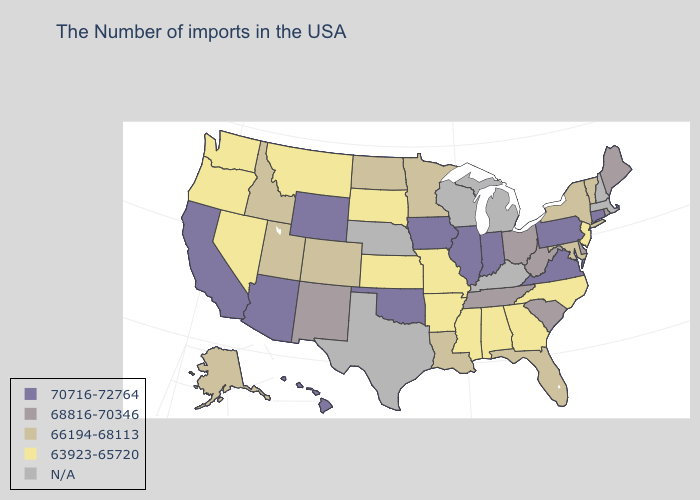What is the value of Alaska?
Write a very short answer. 66194-68113. Among the states that border Connecticut , does Rhode Island have the lowest value?
Concise answer only. No. Among the states that border Iowa , does South Dakota have the highest value?
Write a very short answer. No. Does the first symbol in the legend represent the smallest category?
Answer briefly. No. What is the highest value in the Northeast ?
Short answer required. 70716-72764. Which states have the highest value in the USA?
Concise answer only. Connecticut, Pennsylvania, Virginia, Indiana, Illinois, Iowa, Oklahoma, Wyoming, Arizona, California, Hawaii. What is the value of Michigan?
Be succinct. N/A. Which states have the lowest value in the USA?
Answer briefly. New Jersey, North Carolina, Georgia, Alabama, Mississippi, Missouri, Arkansas, Kansas, South Dakota, Montana, Nevada, Washington, Oregon. Among the states that border Indiana , which have the lowest value?
Quick response, please. Ohio. What is the lowest value in the USA?
Concise answer only. 63923-65720. Name the states that have a value in the range 66194-68113?
Write a very short answer. Vermont, New York, Maryland, Florida, Louisiana, Minnesota, North Dakota, Colorado, Utah, Idaho, Alaska. Does New Jersey have the lowest value in the USA?
Give a very brief answer. Yes. Name the states that have a value in the range 70716-72764?
Answer briefly. Connecticut, Pennsylvania, Virginia, Indiana, Illinois, Iowa, Oklahoma, Wyoming, Arizona, California, Hawaii. How many symbols are there in the legend?
Answer briefly. 5. Does Arizona have the lowest value in the West?
Give a very brief answer. No. 